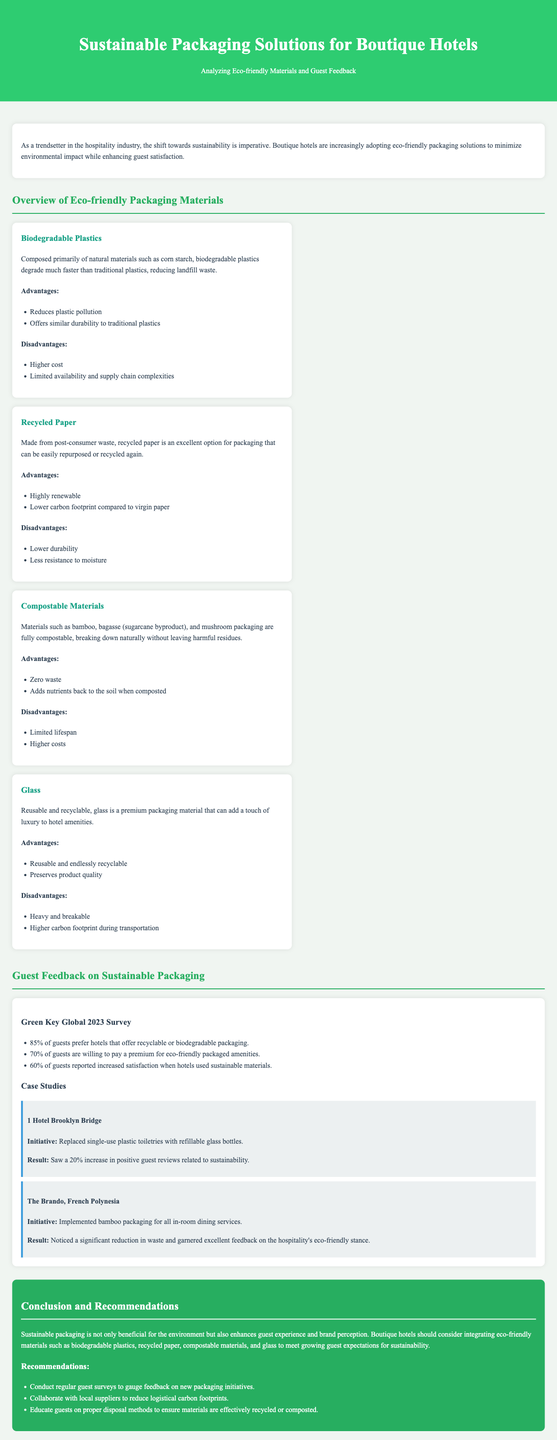What is the title of the document? The title is stated in the header section of the document.
Answer: Sustainable Packaging Solutions for Boutique Hotels What percentage of guests prefer recyclable or biodegradable packaging? This percentage is highlighted in the guest feedback section, specifically from a survey.
Answer: 85% Which material is made from post-consumer waste? The materials section describes various packaging options, identifying one made from post-consumer waste.
Answer: Recycled Paper What initiative did 1 Hotel Brooklyn Bridge implement? The initiative is described in the case study section, detailing a specific change made by the hotel.
Answer: Replaced single-use plastic toiletries with refillable glass bottles What is one advantage of using compostable materials? Advantages are listed under each material in the overview section.
Answer: Zero waste What percentage of guests are willing to pay a premium for eco-friendly packaging? This figure is included in the survey results in the guest feedback section.
Answer: 70% What is a disadvantage of biodegradable plastics? Disadvantages of each material are mentioned in the relevant sections, providing insight into potential limitations.
Answer: Higher cost What type of materials should boutique hotels consider integrating according to the conclusion? The conclusion offers specific suggestions for materials that enhance sustainability.
Answer: Biodegradable plastics, recycled paper, compostable materials, and glass 